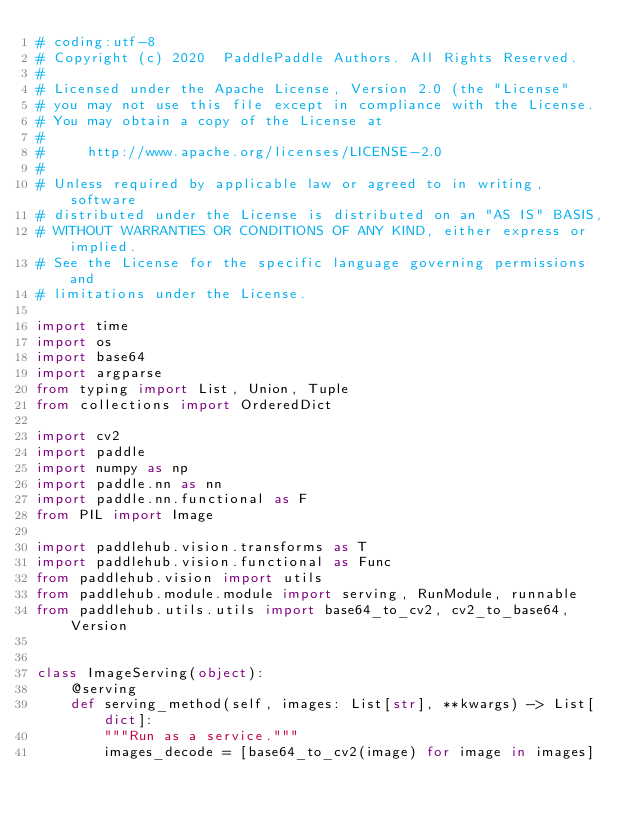<code> <loc_0><loc_0><loc_500><loc_500><_Python_># coding:utf-8
# Copyright (c) 2020  PaddlePaddle Authors. All Rights Reserved.
#
# Licensed under the Apache License, Version 2.0 (the "License"
# you may not use this file except in compliance with the License.
# You may obtain a copy of the License at
#
#     http://www.apache.org/licenses/LICENSE-2.0
#
# Unless required by applicable law or agreed to in writing, software
# distributed under the License is distributed on an "AS IS" BASIS,
# WITHOUT WARRANTIES OR CONDITIONS OF ANY KIND, either express or implied.
# See the License for the specific language governing permissions and
# limitations under the License.

import time
import os
import base64
import argparse
from typing import List, Union, Tuple
from collections import OrderedDict

import cv2
import paddle
import numpy as np
import paddle.nn as nn
import paddle.nn.functional as F
from PIL import Image

import paddlehub.vision.transforms as T
import paddlehub.vision.functional as Func
from paddlehub.vision import utils
from paddlehub.module.module import serving, RunModule, runnable
from paddlehub.utils.utils import base64_to_cv2, cv2_to_base64, Version


class ImageServing(object):
    @serving
    def serving_method(self, images: List[str], **kwargs) -> List[dict]:
        """Run as a service."""
        images_decode = [base64_to_cv2(image) for image in images]</code> 